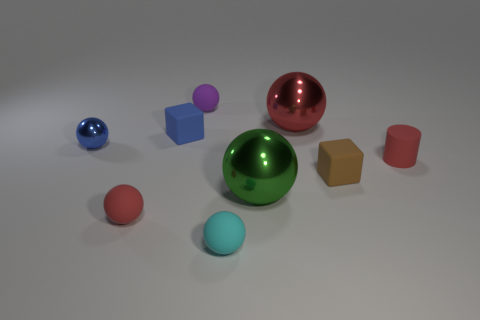There is another object that is the same color as the small metal object; what material is it?
Offer a very short reply. Rubber. The small cylinder has what color?
Your answer should be compact. Red. There is a red matte thing that is on the right side of the tiny red sphere; is there a tiny purple thing that is in front of it?
Keep it short and to the point. No. What material is the tiny cyan sphere?
Offer a terse response. Rubber. Do the small red thing in front of the small rubber cylinder and the big sphere in front of the brown matte thing have the same material?
Provide a short and direct response. No. Is there any other thing of the same color as the cylinder?
Provide a succinct answer. Yes. There is another big thing that is the same shape as the big red thing; what color is it?
Keep it short and to the point. Green. How big is the metal thing that is behind the tiny brown rubber cube and right of the cyan matte ball?
Provide a short and direct response. Large. There is a red object behind the tiny blue metal object; does it have the same shape as the small red object that is left of the tiny cyan matte sphere?
Provide a short and direct response. Yes. What is the shape of the small object that is the same color as the cylinder?
Your response must be concise. Sphere. 